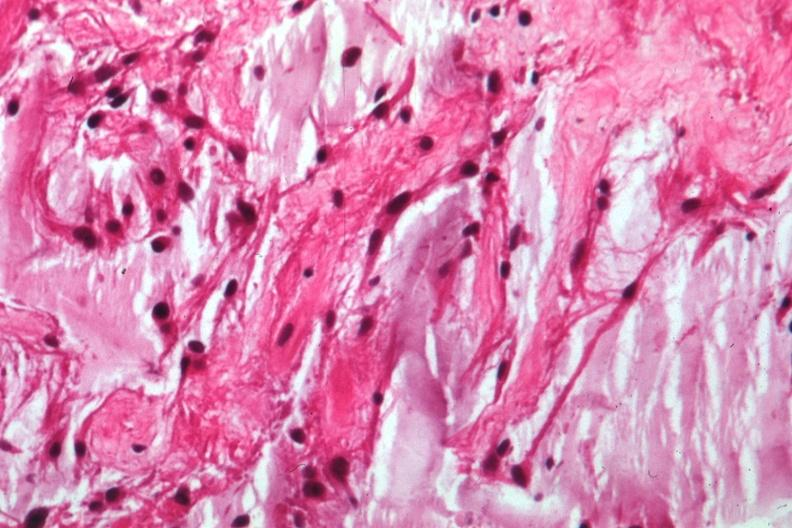does case of peritonitis slide show glioma?
Answer the question using a single word or phrase. No 